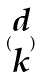Convert formula to latex. <formula><loc_0><loc_0><loc_500><loc_500>( \begin{matrix} d \\ k \end{matrix} )</formula> 